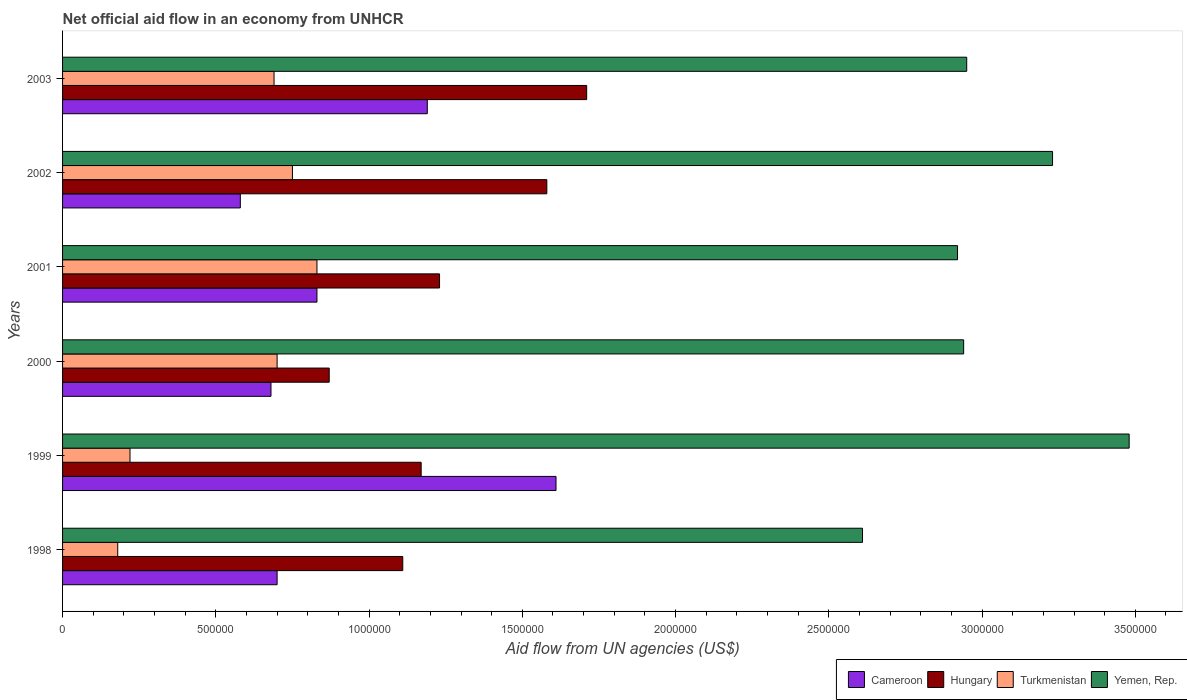How many different coloured bars are there?
Ensure brevity in your answer.  4. How many groups of bars are there?
Offer a very short reply. 6. Are the number of bars per tick equal to the number of legend labels?
Your response must be concise. Yes. Are the number of bars on each tick of the Y-axis equal?
Offer a terse response. Yes. How many bars are there on the 3rd tick from the bottom?
Provide a succinct answer. 4. What is the net official aid flow in Cameroon in 1998?
Your answer should be very brief. 7.00e+05. Across all years, what is the maximum net official aid flow in Cameroon?
Make the answer very short. 1.61e+06. Across all years, what is the minimum net official aid flow in Yemen, Rep.?
Provide a short and direct response. 2.61e+06. In which year was the net official aid flow in Hungary maximum?
Your answer should be compact. 2003. In which year was the net official aid flow in Yemen, Rep. minimum?
Make the answer very short. 1998. What is the total net official aid flow in Cameroon in the graph?
Ensure brevity in your answer.  5.59e+06. What is the difference between the net official aid flow in Yemen, Rep. in 1998 and that in 2000?
Your answer should be compact. -3.30e+05. What is the average net official aid flow in Turkmenistan per year?
Provide a succinct answer. 5.62e+05. In the year 1999, what is the difference between the net official aid flow in Turkmenistan and net official aid flow in Yemen, Rep.?
Your response must be concise. -3.26e+06. What is the ratio of the net official aid flow in Turkmenistan in 1999 to that in 2001?
Give a very brief answer. 0.27. What is the difference between the highest and the second highest net official aid flow in Hungary?
Give a very brief answer. 1.30e+05. What is the difference between the highest and the lowest net official aid flow in Yemen, Rep.?
Ensure brevity in your answer.  8.70e+05. What does the 1st bar from the top in 1999 represents?
Your answer should be very brief. Yemen, Rep. What does the 4th bar from the bottom in 2002 represents?
Ensure brevity in your answer.  Yemen, Rep. How many bars are there?
Provide a short and direct response. 24. Are all the bars in the graph horizontal?
Ensure brevity in your answer.  Yes. How many years are there in the graph?
Ensure brevity in your answer.  6. Are the values on the major ticks of X-axis written in scientific E-notation?
Your answer should be compact. No. Does the graph contain any zero values?
Keep it short and to the point. No. How many legend labels are there?
Give a very brief answer. 4. How are the legend labels stacked?
Keep it short and to the point. Horizontal. What is the title of the graph?
Keep it short and to the point. Net official aid flow in an economy from UNHCR. Does "Lesotho" appear as one of the legend labels in the graph?
Your answer should be very brief. No. What is the label or title of the X-axis?
Provide a short and direct response. Aid flow from UN agencies (US$). What is the Aid flow from UN agencies (US$) in Hungary in 1998?
Give a very brief answer. 1.11e+06. What is the Aid flow from UN agencies (US$) in Yemen, Rep. in 1998?
Keep it short and to the point. 2.61e+06. What is the Aid flow from UN agencies (US$) of Cameroon in 1999?
Ensure brevity in your answer.  1.61e+06. What is the Aid flow from UN agencies (US$) in Hungary in 1999?
Provide a short and direct response. 1.17e+06. What is the Aid flow from UN agencies (US$) of Turkmenistan in 1999?
Your answer should be very brief. 2.20e+05. What is the Aid flow from UN agencies (US$) in Yemen, Rep. in 1999?
Provide a short and direct response. 3.48e+06. What is the Aid flow from UN agencies (US$) in Cameroon in 2000?
Give a very brief answer. 6.80e+05. What is the Aid flow from UN agencies (US$) in Hungary in 2000?
Give a very brief answer. 8.70e+05. What is the Aid flow from UN agencies (US$) of Turkmenistan in 2000?
Ensure brevity in your answer.  7.00e+05. What is the Aid flow from UN agencies (US$) of Yemen, Rep. in 2000?
Your answer should be compact. 2.94e+06. What is the Aid flow from UN agencies (US$) of Cameroon in 2001?
Give a very brief answer. 8.30e+05. What is the Aid flow from UN agencies (US$) of Hungary in 2001?
Your answer should be very brief. 1.23e+06. What is the Aid flow from UN agencies (US$) of Turkmenistan in 2001?
Your response must be concise. 8.30e+05. What is the Aid flow from UN agencies (US$) in Yemen, Rep. in 2001?
Your answer should be compact. 2.92e+06. What is the Aid flow from UN agencies (US$) in Cameroon in 2002?
Keep it short and to the point. 5.80e+05. What is the Aid flow from UN agencies (US$) in Hungary in 2002?
Provide a short and direct response. 1.58e+06. What is the Aid flow from UN agencies (US$) of Turkmenistan in 2002?
Ensure brevity in your answer.  7.50e+05. What is the Aid flow from UN agencies (US$) of Yemen, Rep. in 2002?
Keep it short and to the point. 3.23e+06. What is the Aid flow from UN agencies (US$) of Cameroon in 2003?
Your answer should be very brief. 1.19e+06. What is the Aid flow from UN agencies (US$) in Hungary in 2003?
Ensure brevity in your answer.  1.71e+06. What is the Aid flow from UN agencies (US$) in Turkmenistan in 2003?
Offer a terse response. 6.90e+05. What is the Aid flow from UN agencies (US$) of Yemen, Rep. in 2003?
Keep it short and to the point. 2.95e+06. Across all years, what is the maximum Aid flow from UN agencies (US$) in Cameroon?
Your answer should be compact. 1.61e+06. Across all years, what is the maximum Aid flow from UN agencies (US$) of Hungary?
Ensure brevity in your answer.  1.71e+06. Across all years, what is the maximum Aid flow from UN agencies (US$) in Turkmenistan?
Provide a succinct answer. 8.30e+05. Across all years, what is the maximum Aid flow from UN agencies (US$) of Yemen, Rep.?
Keep it short and to the point. 3.48e+06. Across all years, what is the minimum Aid flow from UN agencies (US$) of Cameroon?
Ensure brevity in your answer.  5.80e+05. Across all years, what is the minimum Aid flow from UN agencies (US$) in Hungary?
Provide a succinct answer. 8.70e+05. Across all years, what is the minimum Aid flow from UN agencies (US$) of Turkmenistan?
Your answer should be very brief. 1.80e+05. Across all years, what is the minimum Aid flow from UN agencies (US$) of Yemen, Rep.?
Provide a short and direct response. 2.61e+06. What is the total Aid flow from UN agencies (US$) of Cameroon in the graph?
Provide a short and direct response. 5.59e+06. What is the total Aid flow from UN agencies (US$) of Hungary in the graph?
Ensure brevity in your answer.  7.67e+06. What is the total Aid flow from UN agencies (US$) of Turkmenistan in the graph?
Offer a very short reply. 3.37e+06. What is the total Aid flow from UN agencies (US$) in Yemen, Rep. in the graph?
Offer a very short reply. 1.81e+07. What is the difference between the Aid flow from UN agencies (US$) of Cameroon in 1998 and that in 1999?
Offer a very short reply. -9.10e+05. What is the difference between the Aid flow from UN agencies (US$) of Yemen, Rep. in 1998 and that in 1999?
Your response must be concise. -8.70e+05. What is the difference between the Aid flow from UN agencies (US$) of Cameroon in 1998 and that in 2000?
Make the answer very short. 2.00e+04. What is the difference between the Aid flow from UN agencies (US$) of Hungary in 1998 and that in 2000?
Offer a very short reply. 2.40e+05. What is the difference between the Aid flow from UN agencies (US$) in Turkmenistan in 1998 and that in 2000?
Your response must be concise. -5.20e+05. What is the difference between the Aid flow from UN agencies (US$) of Yemen, Rep. in 1998 and that in 2000?
Your answer should be very brief. -3.30e+05. What is the difference between the Aid flow from UN agencies (US$) in Cameroon in 1998 and that in 2001?
Offer a terse response. -1.30e+05. What is the difference between the Aid flow from UN agencies (US$) in Turkmenistan in 1998 and that in 2001?
Provide a succinct answer. -6.50e+05. What is the difference between the Aid flow from UN agencies (US$) of Yemen, Rep. in 1998 and that in 2001?
Make the answer very short. -3.10e+05. What is the difference between the Aid flow from UN agencies (US$) of Cameroon in 1998 and that in 2002?
Make the answer very short. 1.20e+05. What is the difference between the Aid flow from UN agencies (US$) in Hungary in 1998 and that in 2002?
Make the answer very short. -4.70e+05. What is the difference between the Aid flow from UN agencies (US$) in Turkmenistan in 1998 and that in 2002?
Ensure brevity in your answer.  -5.70e+05. What is the difference between the Aid flow from UN agencies (US$) of Yemen, Rep. in 1998 and that in 2002?
Keep it short and to the point. -6.20e+05. What is the difference between the Aid flow from UN agencies (US$) of Cameroon in 1998 and that in 2003?
Give a very brief answer. -4.90e+05. What is the difference between the Aid flow from UN agencies (US$) in Hungary in 1998 and that in 2003?
Offer a terse response. -6.00e+05. What is the difference between the Aid flow from UN agencies (US$) of Turkmenistan in 1998 and that in 2003?
Give a very brief answer. -5.10e+05. What is the difference between the Aid flow from UN agencies (US$) of Yemen, Rep. in 1998 and that in 2003?
Make the answer very short. -3.40e+05. What is the difference between the Aid flow from UN agencies (US$) in Cameroon in 1999 and that in 2000?
Offer a terse response. 9.30e+05. What is the difference between the Aid flow from UN agencies (US$) in Turkmenistan in 1999 and that in 2000?
Your answer should be very brief. -4.80e+05. What is the difference between the Aid flow from UN agencies (US$) of Yemen, Rep. in 1999 and that in 2000?
Keep it short and to the point. 5.40e+05. What is the difference between the Aid flow from UN agencies (US$) in Cameroon in 1999 and that in 2001?
Provide a succinct answer. 7.80e+05. What is the difference between the Aid flow from UN agencies (US$) in Turkmenistan in 1999 and that in 2001?
Your answer should be compact. -6.10e+05. What is the difference between the Aid flow from UN agencies (US$) in Yemen, Rep. in 1999 and that in 2001?
Your response must be concise. 5.60e+05. What is the difference between the Aid flow from UN agencies (US$) of Cameroon in 1999 and that in 2002?
Your response must be concise. 1.03e+06. What is the difference between the Aid flow from UN agencies (US$) in Hungary in 1999 and that in 2002?
Offer a very short reply. -4.10e+05. What is the difference between the Aid flow from UN agencies (US$) in Turkmenistan in 1999 and that in 2002?
Give a very brief answer. -5.30e+05. What is the difference between the Aid flow from UN agencies (US$) of Yemen, Rep. in 1999 and that in 2002?
Your answer should be compact. 2.50e+05. What is the difference between the Aid flow from UN agencies (US$) in Cameroon in 1999 and that in 2003?
Your answer should be very brief. 4.20e+05. What is the difference between the Aid flow from UN agencies (US$) in Hungary in 1999 and that in 2003?
Keep it short and to the point. -5.40e+05. What is the difference between the Aid flow from UN agencies (US$) of Turkmenistan in 1999 and that in 2003?
Give a very brief answer. -4.70e+05. What is the difference between the Aid flow from UN agencies (US$) of Yemen, Rep. in 1999 and that in 2003?
Give a very brief answer. 5.30e+05. What is the difference between the Aid flow from UN agencies (US$) in Cameroon in 2000 and that in 2001?
Make the answer very short. -1.50e+05. What is the difference between the Aid flow from UN agencies (US$) of Hungary in 2000 and that in 2001?
Your answer should be compact. -3.60e+05. What is the difference between the Aid flow from UN agencies (US$) of Turkmenistan in 2000 and that in 2001?
Your answer should be compact. -1.30e+05. What is the difference between the Aid flow from UN agencies (US$) of Yemen, Rep. in 2000 and that in 2001?
Make the answer very short. 2.00e+04. What is the difference between the Aid flow from UN agencies (US$) in Cameroon in 2000 and that in 2002?
Give a very brief answer. 1.00e+05. What is the difference between the Aid flow from UN agencies (US$) of Hungary in 2000 and that in 2002?
Give a very brief answer. -7.10e+05. What is the difference between the Aid flow from UN agencies (US$) in Yemen, Rep. in 2000 and that in 2002?
Offer a very short reply. -2.90e+05. What is the difference between the Aid flow from UN agencies (US$) in Cameroon in 2000 and that in 2003?
Your answer should be compact. -5.10e+05. What is the difference between the Aid flow from UN agencies (US$) of Hungary in 2000 and that in 2003?
Ensure brevity in your answer.  -8.40e+05. What is the difference between the Aid flow from UN agencies (US$) in Turkmenistan in 2000 and that in 2003?
Provide a short and direct response. 10000. What is the difference between the Aid flow from UN agencies (US$) of Cameroon in 2001 and that in 2002?
Your answer should be very brief. 2.50e+05. What is the difference between the Aid flow from UN agencies (US$) in Hungary in 2001 and that in 2002?
Offer a very short reply. -3.50e+05. What is the difference between the Aid flow from UN agencies (US$) in Yemen, Rep. in 2001 and that in 2002?
Offer a terse response. -3.10e+05. What is the difference between the Aid flow from UN agencies (US$) of Cameroon in 2001 and that in 2003?
Make the answer very short. -3.60e+05. What is the difference between the Aid flow from UN agencies (US$) in Hungary in 2001 and that in 2003?
Make the answer very short. -4.80e+05. What is the difference between the Aid flow from UN agencies (US$) in Yemen, Rep. in 2001 and that in 2003?
Ensure brevity in your answer.  -3.00e+04. What is the difference between the Aid flow from UN agencies (US$) in Cameroon in 2002 and that in 2003?
Provide a succinct answer. -6.10e+05. What is the difference between the Aid flow from UN agencies (US$) of Hungary in 2002 and that in 2003?
Make the answer very short. -1.30e+05. What is the difference between the Aid flow from UN agencies (US$) in Turkmenistan in 2002 and that in 2003?
Keep it short and to the point. 6.00e+04. What is the difference between the Aid flow from UN agencies (US$) of Yemen, Rep. in 2002 and that in 2003?
Your answer should be very brief. 2.80e+05. What is the difference between the Aid flow from UN agencies (US$) of Cameroon in 1998 and the Aid flow from UN agencies (US$) of Hungary in 1999?
Provide a succinct answer. -4.70e+05. What is the difference between the Aid flow from UN agencies (US$) of Cameroon in 1998 and the Aid flow from UN agencies (US$) of Yemen, Rep. in 1999?
Your answer should be very brief. -2.78e+06. What is the difference between the Aid flow from UN agencies (US$) of Hungary in 1998 and the Aid flow from UN agencies (US$) of Turkmenistan in 1999?
Your response must be concise. 8.90e+05. What is the difference between the Aid flow from UN agencies (US$) of Hungary in 1998 and the Aid flow from UN agencies (US$) of Yemen, Rep. in 1999?
Your response must be concise. -2.37e+06. What is the difference between the Aid flow from UN agencies (US$) in Turkmenistan in 1998 and the Aid flow from UN agencies (US$) in Yemen, Rep. in 1999?
Your response must be concise. -3.30e+06. What is the difference between the Aid flow from UN agencies (US$) in Cameroon in 1998 and the Aid flow from UN agencies (US$) in Hungary in 2000?
Your answer should be compact. -1.70e+05. What is the difference between the Aid flow from UN agencies (US$) of Cameroon in 1998 and the Aid flow from UN agencies (US$) of Turkmenistan in 2000?
Give a very brief answer. 0. What is the difference between the Aid flow from UN agencies (US$) in Cameroon in 1998 and the Aid flow from UN agencies (US$) in Yemen, Rep. in 2000?
Offer a very short reply. -2.24e+06. What is the difference between the Aid flow from UN agencies (US$) in Hungary in 1998 and the Aid flow from UN agencies (US$) in Turkmenistan in 2000?
Your answer should be compact. 4.10e+05. What is the difference between the Aid flow from UN agencies (US$) of Hungary in 1998 and the Aid flow from UN agencies (US$) of Yemen, Rep. in 2000?
Your answer should be very brief. -1.83e+06. What is the difference between the Aid flow from UN agencies (US$) in Turkmenistan in 1998 and the Aid flow from UN agencies (US$) in Yemen, Rep. in 2000?
Provide a succinct answer. -2.76e+06. What is the difference between the Aid flow from UN agencies (US$) in Cameroon in 1998 and the Aid flow from UN agencies (US$) in Hungary in 2001?
Offer a very short reply. -5.30e+05. What is the difference between the Aid flow from UN agencies (US$) of Cameroon in 1998 and the Aid flow from UN agencies (US$) of Yemen, Rep. in 2001?
Offer a very short reply. -2.22e+06. What is the difference between the Aid flow from UN agencies (US$) in Hungary in 1998 and the Aid flow from UN agencies (US$) in Yemen, Rep. in 2001?
Provide a succinct answer. -1.81e+06. What is the difference between the Aid flow from UN agencies (US$) in Turkmenistan in 1998 and the Aid flow from UN agencies (US$) in Yemen, Rep. in 2001?
Your response must be concise. -2.74e+06. What is the difference between the Aid flow from UN agencies (US$) of Cameroon in 1998 and the Aid flow from UN agencies (US$) of Hungary in 2002?
Your response must be concise. -8.80e+05. What is the difference between the Aid flow from UN agencies (US$) of Cameroon in 1998 and the Aid flow from UN agencies (US$) of Turkmenistan in 2002?
Your answer should be compact. -5.00e+04. What is the difference between the Aid flow from UN agencies (US$) in Cameroon in 1998 and the Aid flow from UN agencies (US$) in Yemen, Rep. in 2002?
Offer a very short reply. -2.53e+06. What is the difference between the Aid flow from UN agencies (US$) of Hungary in 1998 and the Aid flow from UN agencies (US$) of Turkmenistan in 2002?
Offer a terse response. 3.60e+05. What is the difference between the Aid flow from UN agencies (US$) in Hungary in 1998 and the Aid flow from UN agencies (US$) in Yemen, Rep. in 2002?
Offer a terse response. -2.12e+06. What is the difference between the Aid flow from UN agencies (US$) in Turkmenistan in 1998 and the Aid flow from UN agencies (US$) in Yemen, Rep. in 2002?
Ensure brevity in your answer.  -3.05e+06. What is the difference between the Aid flow from UN agencies (US$) of Cameroon in 1998 and the Aid flow from UN agencies (US$) of Hungary in 2003?
Make the answer very short. -1.01e+06. What is the difference between the Aid flow from UN agencies (US$) of Cameroon in 1998 and the Aid flow from UN agencies (US$) of Turkmenistan in 2003?
Offer a very short reply. 10000. What is the difference between the Aid flow from UN agencies (US$) in Cameroon in 1998 and the Aid flow from UN agencies (US$) in Yemen, Rep. in 2003?
Offer a terse response. -2.25e+06. What is the difference between the Aid flow from UN agencies (US$) in Hungary in 1998 and the Aid flow from UN agencies (US$) in Turkmenistan in 2003?
Provide a short and direct response. 4.20e+05. What is the difference between the Aid flow from UN agencies (US$) in Hungary in 1998 and the Aid flow from UN agencies (US$) in Yemen, Rep. in 2003?
Your answer should be very brief. -1.84e+06. What is the difference between the Aid flow from UN agencies (US$) of Turkmenistan in 1998 and the Aid flow from UN agencies (US$) of Yemen, Rep. in 2003?
Provide a succinct answer. -2.77e+06. What is the difference between the Aid flow from UN agencies (US$) of Cameroon in 1999 and the Aid flow from UN agencies (US$) of Hungary in 2000?
Ensure brevity in your answer.  7.40e+05. What is the difference between the Aid flow from UN agencies (US$) of Cameroon in 1999 and the Aid flow from UN agencies (US$) of Turkmenistan in 2000?
Offer a terse response. 9.10e+05. What is the difference between the Aid flow from UN agencies (US$) of Cameroon in 1999 and the Aid flow from UN agencies (US$) of Yemen, Rep. in 2000?
Provide a succinct answer. -1.33e+06. What is the difference between the Aid flow from UN agencies (US$) of Hungary in 1999 and the Aid flow from UN agencies (US$) of Yemen, Rep. in 2000?
Give a very brief answer. -1.77e+06. What is the difference between the Aid flow from UN agencies (US$) in Turkmenistan in 1999 and the Aid flow from UN agencies (US$) in Yemen, Rep. in 2000?
Provide a succinct answer. -2.72e+06. What is the difference between the Aid flow from UN agencies (US$) of Cameroon in 1999 and the Aid flow from UN agencies (US$) of Hungary in 2001?
Offer a terse response. 3.80e+05. What is the difference between the Aid flow from UN agencies (US$) of Cameroon in 1999 and the Aid flow from UN agencies (US$) of Turkmenistan in 2001?
Your answer should be very brief. 7.80e+05. What is the difference between the Aid flow from UN agencies (US$) in Cameroon in 1999 and the Aid flow from UN agencies (US$) in Yemen, Rep. in 2001?
Your answer should be compact. -1.31e+06. What is the difference between the Aid flow from UN agencies (US$) in Hungary in 1999 and the Aid flow from UN agencies (US$) in Turkmenistan in 2001?
Ensure brevity in your answer.  3.40e+05. What is the difference between the Aid flow from UN agencies (US$) in Hungary in 1999 and the Aid flow from UN agencies (US$) in Yemen, Rep. in 2001?
Offer a terse response. -1.75e+06. What is the difference between the Aid flow from UN agencies (US$) of Turkmenistan in 1999 and the Aid flow from UN agencies (US$) of Yemen, Rep. in 2001?
Keep it short and to the point. -2.70e+06. What is the difference between the Aid flow from UN agencies (US$) of Cameroon in 1999 and the Aid flow from UN agencies (US$) of Hungary in 2002?
Your response must be concise. 3.00e+04. What is the difference between the Aid flow from UN agencies (US$) in Cameroon in 1999 and the Aid flow from UN agencies (US$) in Turkmenistan in 2002?
Ensure brevity in your answer.  8.60e+05. What is the difference between the Aid flow from UN agencies (US$) of Cameroon in 1999 and the Aid flow from UN agencies (US$) of Yemen, Rep. in 2002?
Provide a succinct answer. -1.62e+06. What is the difference between the Aid flow from UN agencies (US$) of Hungary in 1999 and the Aid flow from UN agencies (US$) of Yemen, Rep. in 2002?
Give a very brief answer. -2.06e+06. What is the difference between the Aid flow from UN agencies (US$) in Turkmenistan in 1999 and the Aid flow from UN agencies (US$) in Yemen, Rep. in 2002?
Provide a short and direct response. -3.01e+06. What is the difference between the Aid flow from UN agencies (US$) in Cameroon in 1999 and the Aid flow from UN agencies (US$) in Turkmenistan in 2003?
Your answer should be very brief. 9.20e+05. What is the difference between the Aid flow from UN agencies (US$) of Cameroon in 1999 and the Aid flow from UN agencies (US$) of Yemen, Rep. in 2003?
Provide a short and direct response. -1.34e+06. What is the difference between the Aid flow from UN agencies (US$) in Hungary in 1999 and the Aid flow from UN agencies (US$) in Yemen, Rep. in 2003?
Your answer should be compact. -1.78e+06. What is the difference between the Aid flow from UN agencies (US$) of Turkmenistan in 1999 and the Aid flow from UN agencies (US$) of Yemen, Rep. in 2003?
Provide a succinct answer. -2.73e+06. What is the difference between the Aid flow from UN agencies (US$) in Cameroon in 2000 and the Aid flow from UN agencies (US$) in Hungary in 2001?
Make the answer very short. -5.50e+05. What is the difference between the Aid flow from UN agencies (US$) of Cameroon in 2000 and the Aid flow from UN agencies (US$) of Yemen, Rep. in 2001?
Ensure brevity in your answer.  -2.24e+06. What is the difference between the Aid flow from UN agencies (US$) of Hungary in 2000 and the Aid flow from UN agencies (US$) of Turkmenistan in 2001?
Provide a short and direct response. 4.00e+04. What is the difference between the Aid flow from UN agencies (US$) of Hungary in 2000 and the Aid flow from UN agencies (US$) of Yemen, Rep. in 2001?
Make the answer very short. -2.05e+06. What is the difference between the Aid flow from UN agencies (US$) of Turkmenistan in 2000 and the Aid flow from UN agencies (US$) of Yemen, Rep. in 2001?
Provide a short and direct response. -2.22e+06. What is the difference between the Aid flow from UN agencies (US$) in Cameroon in 2000 and the Aid flow from UN agencies (US$) in Hungary in 2002?
Your answer should be very brief. -9.00e+05. What is the difference between the Aid flow from UN agencies (US$) in Cameroon in 2000 and the Aid flow from UN agencies (US$) in Yemen, Rep. in 2002?
Ensure brevity in your answer.  -2.55e+06. What is the difference between the Aid flow from UN agencies (US$) of Hungary in 2000 and the Aid flow from UN agencies (US$) of Yemen, Rep. in 2002?
Your answer should be very brief. -2.36e+06. What is the difference between the Aid flow from UN agencies (US$) of Turkmenistan in 2000 and the Aid flow from UN agencies (US$) of Yemen, Rep. in 2002?
Provide a succinct answer. -2.53e+06. What is the difference between the Aid flow from UN agencies (US$) in Cameroon in 2000 and the Aid flow from UN agencies (US$) in Hungary in 2003?
Offer a terse response. -1.03e+06. What is the difference between the Aid flow from UN agencies (US$) of Cameroon in 2000 and the Aid flow from UN agencies (US$) of Turkmenistan in 2003?
Your response must be concise. -10000. What is the difference between the Aid flow from UN agencies (US$) of Cameroon in 2000 and the Aid flow from UN agencies (US$) of Yemen, Rep. in 2003?
Your response must be concise. -2.27e+06. What is the difference between the Aid flow from UN agencies (US$) in Hungary in 2000 and the Aid flow from UN agencies (US$) in Turkmenistan in 2003?
Offer a very short reply. 1.80e+05. What is the difference between the Aid flow from UN agencies (US$) in Hungary in 2000 and the Aid flow from UN agencies (US$) in Yemen, Rep. in 2003?
Provide a succinct answer. -2.08e+06. What is the difference between the Aid flow from UN agencies (US$) in Turkmenistan in 2000 and the Aid flow from UN agencies (US$) in Yemen, Rep. in 2003?
Offer a very short reply. -2.25e+06. What is the difference between the Aid flow from UN agencies (US$) of Cameroon in 2001 and the Aid flow from UN agencies (US$) of Hungary in 2002?
Offer a very short reply. -7.50e+05. What is the difference between the Aid flow from UN agencies (US$) in Cameroon in 2001 and the Aid flow from UN agencies (US$) in Turkmenistan in 2002?
Offer a very short reply. 8.00e+04. What is the difference between the Aid flow from UN agencies (US$) in Cameroon in 2001 and the Aid flow from UN agencies (US$) in Yemen, Rep. in 2002?
Ensure brevity in your answer.  -2.40e+06. What is the difference between the Aid flow from UN agencies (US$) in Hungary in 2001 and the Aid flow from UN agencies (US$) in Yemen, Rep. in 2002?
Keep it short and to the point. -2.00e+06. What is the difference between the Aid flow from UN agencies (US$) in Turkmenistan in 2001 and the Aid flow from UN agencies (US$) in Yemen, Rep. in 2002?
Make the answer very short. -2.40e+06. What is the difference between the Aid flow from UN agencies (US$) of Cameroon in 2001 and the Aid flow from UN agencies (US$) of Hungary in 2003?
Make the answer very short. -8.80e+05. What is the difference between the Aid flow from UN agencies (US$) of Cameroon in 2001 and the Aid flow from UN agencies (US$) of Turkmenistan in 2003?
Make the answer very short. 1.40e+05. What is the difference between the Aid flow from UN agencies (US$) in Cameroon in 2001 and the Aid flow from UN agencies (US$) in Yemen, Rep. in 2003?
Your answer should be compact. -2.12e+06. What is the difference between the Aid flow from UN agencies (US$) of Hungary in 2001 and the Aid flow from UN agencies (US$) of Turkmenistan in 2003?
Your answer should be compact. 5.40e+05. What is the difference between the Aid flow from UN agencies (US$) in Hungary in 2001 and the Aid flow from UN agencies (US$) in Yemen, Rep. in 2003?
Offer a very short reply. -1.72e+06. What is the difference between the Aid flow from UN agencies (US$) in Turkmenistan in 2001 and the Aid flow from UN agencies (US$) in Yemen, Rep. in 2003?
Provide a succinct answer. -2.12e+06. What is the difference between the Aid flow from UN agencies (US$) in Cameroon in 2002 and the Aid flow from UN agencies (US$) in Hungary in 2003?
Provide a short and direct response. -1.13e+06. What is the difference between the Aid flow from UN agencies (US$) in Cameroon in 2002 and the Aid flow from UN agencies (US$) in Yemen, Rep. in 2003?
Your answer should be compact. -2.37e+06. What is the difference between the Aid flow from UN agencies (US$) in Hungary in 2002 and the Aid flow from UN agencies (US$) in Turkmenistan in 2003?
Give a very brief answer. 8.90e+05. What is the difference between the Aid flow from UN agencies (US$) of Hungary in 2002 and the Aid flow from UN agencies (US$) of Yemen, Rep. in 2003?
Keep it short and to the point. -1.37e+06. What is the difference between the Aid flow from UN agencies (US$) of Turkmenistan in 2002 and the Aid flow from UN agencies (US$) of Yemen, Rep. in 2003?
Offer a terse response. -2.20e+06. What is the average Aid flow from UN agencies (US$) in Cameroon per year?
Your response must be concise. 9.32e+05. What is the average Aid flow from UN agencies (US$) in Hungary per year?
Give a very brief answer. 1.28e+06. What is the average Aid flow from UN agencies (US$) in Turkmenistan per year?
Your response must be concise. 5.62e+05. What is the average Aid flow from UN agencies (US$) of Yemen, Rep. per year?
Keep it short and to the point. 3.02e+06. In the year 1998, what is the difference between the Aid flow from UN agencies (US$) in Cameroon and Aid flow from UN agencies (US$) in Hungary?
Provide a succinct answer. -4.10e+05. In the year 1998, what is the difference between the Aid flow from UN agencies (US$) of Cameroon and Aid flow from UN agencies (US$) of Turkmenistan?
Offer a very short reply. 5.20e+05. In the year 1998, what is the difference between the Aid flow from UN agencies (US$) in Cameroon and Aid flow from UN agencies (US$) in Yemen, Rep.?
Keep it short and to the point. -1.91e+06. In the year 1998, what is the difference between the Aid flow from UN agencies (US$) of Hungary and Aid flow from UN agencies (US$) of Turkmenistan?
Make the answer very short. 9.30e+05. In the year 1998, what is the difference between the Aid flow from UN agencies (US$) of Hungary and Aid flow from UN agencies (US$) of Yemen, Rep.?
Offer a terse response. -1.50e+06. In the year 1998, what is the difference between the Aid flow from UN agencies (US$) of Turkmenistan and Aid flow from UN agencies (US$) of Yemen, Rep.?
Your answer should be very brief. -2.43e+06. In the year 1999, what is the difference between the Aid flow from UN agencies (US$) of Cameroon and Aid flow from UN agencies (US$) of Turkmenistan?
Your answer should be compact. 1.39e+06. In the year 1999, what is the difference between the Aid flow from UN agencies (US$) of Cameroon and Aid flow from UN agencies (US$) of Yemen, Rep.?
Your answer should be compact. -1.87e+06. In the year 1999, what is the difference between the Aid flow from UN agencies (US$) of Hungary and Aid flow from UN agencies (US$) of Turkmenistan?
Keep it short and to the point. 9.50e+05. In the year 1999, what is the difference between the Aid flow from UN agencies (US$) in Hungary and Aid flow from UN agencies (US$) in Yemen, Rep.?
Offer a terse response. -2.31e+06. In the year 1999, what is the difference between the Aid flow from UN agencies (US$) of Turkmenistan and Aid flow from UN agencies (US$) of Yemen, Rep.?
Make the answer very short. -3.26e+06. In the year 2000, what is the difference between the Aid flow from UN agencies (US$) in Cameroon and Aid flow from UN agencies (US$) in Hungary?
Keep it short and to the point. -1.90e+05. In the year 2000, what is the difference between the Aid flow from UN agencies (US$) in Cameroon and Aid flow from UN agencies (US$) in Yemen, Rep.?
Provide a succinct answer. -2.26e+06. In the year 2000, what is the difference between the Aid flow from UN agencies (US$) of Hungary and Aid flow from UN agencies (US$) of Yemen, Rep.?
Your response must be concise. -2.07e+06. In the year 2000, what is the difference between the Aid flow from UN agencies (US$) in Turkmenistan and Aid flow from UN agencies (US$) in Yemen, Rep.?
Offer a very short reply. -2.24e+06. In the year 2001, what is the difference between the Aid flow from UN agencies (US$) in Cameroon and Aid flow from UN agencies (US$) in Hungary?
Keep it short and to the point. -4.00e+05. In the year 2001, what is the difference between the Aid flow from UN agencies (US$) of Cameroon and Aid flow from UN agencies (US$) of Turkmenistan?
Offer a very short reply. 0. In the year 2001, what is the difference between the Aid flow from UN agencies (US$) of Cameroon and Aid flow from UN agencies (US$) of Yemen, Rep.?
Give a very brief answer. -2.09e+06. In the year 2001, what is the difference between the Aid flow from UN agencies (US$) of Hungary and Aid flow from UN agencies (US$) of Turkmenistan?
Your response must be concise. 4.00e+05. In the year 2001, what is the difference between the Aid flow from UN agencies (US$) of Hungary and Aid flow from UN agencies (US$) of Yemen, Rep.?
Make the answer very short. -1.69e+06. In the year 2001, what is the difference between the Aid flow from UN agencies (US$) in Turkmenistan and Aid flow from UN agencies (US$) in Yemen, Rep.?
Give a very brief answer. -2.09e+06. In the year 2002, what is the difference between the Aid flow from UN agencies (US$) of Cameroon and Aid flow from UN agencies (US$) of Yemen, Rep.?
Offer a terse response. -2.65e+06. In the year 2002, what is the difference between the Aid flow from UN agencies (US$) in Hungary and Aid flow from UN agencies (US$) in Turkmenistan?
Offer a terse response. 8.30e+05. In the year 2002, what is the difference between the Aid flow from UN agencies (US$) of Hungary and Aid flow from UN agencies (US$) of Yemen, Rep.?
Your answer should be compact. -1.65e+06. In the year 2002, what is the difference between the Aid flow from UN agencies (US$) of Turkmenistan and Aid flow from UN agencies (US$) of Yemen, Rep.?
Your response must be concise. -2.48e+06. In the year 2003, what is the difference between the Aid flow from UN agencies (US$) of Cameroon and Aid flow from UN agencies (US$) of Hungary?
Keep it short and to the point. -5.20e+05. In the year 2003, what is the difference between the Aid flow from UN agencies (US$) in Cameroon and Aid flow from UN agencies (US$) in Yemen, Rep.?
Provide a succinct answer. -1.76e+06. In the year 2003, what is the difference between the Aid flow from UN agencies (US$) in Hungary and Aid flow from UN agencies (US$) in Turkmenistan?
Offer a very short reply. 1.02e+06. In the year 2003, what is the difference between the Aid flow from UN agencies (US$) in Hungary and Aid flow from UN agencies (US$) in Yemen, Rep.?
Make the answer very short. -1.24e+06. In the year 2003, what is the difference between the Aid flow from UN agencies (US$) in Turkmenistan and Aid flow from UN agencies (US$) in Yemen, Rep.?
Make the answer very short. -2.26e+06. What is the ratio of the Aid flow from UN agencies (US$) of Cameroon in 1998 to that in 1999?
Give a very brief answer. 0.43. What is the ratio of the Aid flow from UN agencies (US$) in Hungary in 1998 to that in 1999?
Ensure brevity in your answer.  0.95. What is the ratio of the Aid flow from UN agencies (US$) in Turkmenistan in 1998 to that in 1999?
Give a very brief answer. 0.82. What is the ratio of the Aid flow from UN agencies (US$) of Yemen, Rep. in 1998 to that in 1999?
Offer a very short reply. 0.75. What is the ratio of the Aid flow from UN agencies (US$) of Cameroon in 1998 to that in 2000?
Your response must be concise. 1.03. What is the ratio of the Aid flow from UN agencies (US$) in Hungary in 1998 to that in 2000?
Your answer should be very brief. 1.28. What is the ratio of the Aid flow from UN agencies (US$) in Turkmenistan in 1998 to that in 2000?
Your response must be concise. 0.26. What is the ratio of the Aid flow from UN agencies (US$) of Yemen, Rep. in 1998 to that in 2000?
Provide a short and direct response. 0.89. What is the ratio of the Aid flow from UN agencies (US$) in Cameroon in 1998 to that in 2001?
Provide a short and direct response. 0.84. What is the ratio of the Aid flow from UN agencies (US$) in Hungary in 1998 to that in 2001?
Give a very brief answer. 0.9. What is the ratio of the Aid flow from UN agencies (US$) of Turkmenistan in 1998 to that in 2001?
Offer a very short reply. 0.22. What is the ratio of the Aid flow from UN agencies (US$) of Yemen, Rep. in 1998 to that in 2001?
Offer a very short reply. 0.89. What is the ratio of the Aid flow from UN agencies (US$) in Cameroon in 1998 to that in 2002?
Offer a very short reply. 1.21. What is the ratio of the Aid flow from UN agencies (US$) in Hungary in 1998 to that in 2002?
Offer a terse response. 0.7. What is the ratio of the Aid flow from UN agencies (US$) of Turkmenistan in 1998 to that in 2002?
Keep it short and to the point. 0.24. What is the ratio of the Aid flow from UN agencies (US$) of Yemen, Rep. in 1998 to that in 2002?
Keep it short and to the point. 0.81. What is the ratio of the Aid flow from UN agencies (US$) in Cameroon in 1998 to that in 2003?
Your answer should be very brief. 0.59. What is the ratio of the Aid flow from UN agencies (US$) of Hungary in 1998 to that in 2003?
Offer a very short reply. 0.65. What is the ratio of the Aid flow from UN agencies (US$) of Turkmenistan in 1998 to that in 2003?
Your response must be concise. 0.26. What is the ratio of the Aid flow from UN agencies (US$) in Yemen, Rep. in 1998 to that in 2003?
Your response must be concise. 0.88. What is the ratio of the Aid flow from UN agencies (US$) in Cameroon in 1999 to that in 2000?
Your answer should be compact. 2.37. What is the ratio of the Aid flow from UN agencies (US$) in Hungary in 1999 to that in 2000?
Give a very brief answer. 1.34. What is the ratio of the Aid flow from UN agencies (US$) of Turkmenistan in 1999 to that in 2000?
Offer a very short reply. 0.31. What is the ratio of the Aid flow from UN agencies (US$) in Yemen, Rep. in 1999 to that in 2000?
Ensure brevity in your answer.  1.18. What is the ratio of the Aid flow from UN agencies (US$) in Cameroon in 1999 to that in 2001?
Give a very brief answer. 1.94. What is the ratio of the Aid flow from UN agencies (US$) of Hungary in 1999 to that in 2001?
Ensure brevity in your answer.  0.95. What is the ratio of the Aid flow from UN agencies (US$) of Turkmenistan in 1999 to that in 2001?
Keep it short and to the point. 0.27. What is the ratio of the Aid flow from UN agencies (US$) in Yemen, Rep. in 1999 to that in 2001?
Your answer should be compact. 1.19. What is the ratio of the Aid flow from UN agencies (US$) of Cameroon in 1999 to that in 2002?
Provide a short and direct response. 2.78. What is the ratio of the Aid flow from UN agencies (US$) in Hungary in 1999 to that in 2002?
Provide a short and direct response. 0.74. What is the ratio of the Aid flow from UN agencies (US$) in Turkmenistan in 1999 to that in 2002?
Give a very brief answer. 0.29. What is the ratio of the Aid flow from UN agencies (US$) of Yemen, Rep. in 1999 to that in 2002?
Your answer should be compact. 1.08. What is the ratio of the Aid flow from UN agencies (US$) of Cameroon in 1999 to that in 2003?
Your answer should be very brief. 1.35. What is the ratio of the Aid flow from UN agencies (US$) in Hungary in 1999 to that in 2003?
Offer a very short reply. 0.68. What is the ratio of the Aid flow from UN agencies (US$) in Turkmenistan in 1999 to that in 2003?
Provide a succinct answer. 0.32. What is the ratio of the Aid flow from UN agencies (US$) in Yemen, Rep. in 1999 to that in 2003?
Offer a very short reply. 1.18. What is the ratio of the Aid flow from UN agencies (US$) of Cameroon in 2000 to that in 2001?
Provide a short and direct response. 0.82. What is the ratio of the Aid flow from UN agencies (US$) in Hungary in 2000 to that in 2001?
Ensure brevity in your answer.  0.71. What is the ratio of the Aid flow from UN agencies (US$) of Turkmenistan in 2000 to that in 2001?
Offer a terse response. 0.84. What is the ratio of the Aid flow from UN agencies (US$) of Yemen, Rep. in 2000 to that in 2001?
Give a very brief answer. 1.01. What is the ratio of the Aid flow from UN agencies (US$) of Cameroon in 2000 to that in 2002?
Offer a terse response. 1.17. What is the ratio of the Aid flow from UN agencies (US$) of Hungary in 2000 to that in 2002?
Give a very brief answer. 0.55. What is the ratio of the Aid flow from UN agencies (US$) in Turkmenistan in 2000 to that in 2002?
Your response must be concise. 0.93. What is the ratio of the Aid flow from UN agencies (US$) in Yemen, Rep. in 2000 to that in 2002?
Provide a succinct answer. 0.91. What is the ratio of the Aid flow from UN agencies (US$) in Hungary in 2000 to that in 2003?
Offer a terse response. 0.51. What is the ratio of the Aid flow from UN agencies (US$) in Turkmenistan in 2000 to that in 2003?
Your response must be concise. 1.01. What is the ratio of the Aid flow from UN agencies (US$) in Cameroon in 2001 to that in 2002?
Keep it short and to the point. 1.43. What is the ratio of the Aid flow from UN agencies (US$) of Hungary in 2001 to that in 2002?
Your answer should be compact. 0.78. What is the ratio of the Aid flow from UN agencies (US$) in Turkmenistan in 2001 to that in 2002?
Provide a short and direct response. 1.11. What is the ratio of the Aid flow from UN agencies (US$) of Yemen, Rep. in 2001 to that in 2002?
Provide a short and direct response. 0.9. What is the ratio of the Aid flow from UN agencies (US$) in Cameroon in 2001 to that in 2003?
Give a very brief answer. 0.7. What is the ratio of the Aid flow from UN agencies (US$) in Hungary in 2001 to that in 2003?
Make the answer very short. 0.72. What is the ratio of the Aid flow from UN agencies (US$) in Turkmenistan in 2001 to that in 2003?
Your answer should be compact. 1.2. What is the ratio of the Aid flow from UN agencies (US$) of Cameroon in 2002 to that in 2003?
Provide a succinct answer. 0.49. What is the ratio of the Aid flow from UN agencies (US$) of Hungary in 2002 to that in 2003?
Your answer should be very brief. 0.92. What is the ratio of the Aid flow from UN agencies (US$) in Turkmenistan in 2002 to that in 2003?
Offer a terse response. 1.09. What is the ratio of the Aid flow from UN agencies (US$) in Yemen, Rep. in 2002 to that in 2003?
Keep it short and to the point. 1.09. What is the difference between the highest and the second highest Aid flow from UN agencies (US$) of Cameroon?
Offer a very short reply. 4.20e+05. What is the difference between the highest and the second highest Aid flow from UN agencies (US$) in Hungary?
Ensure brevity in your answer.  1.30e+05. What is the difference between the highest and the lowest Aid flow from UN agencies (US$) of Cameroon?
Make the answer very short. 1.03e+06. What is the difference between the highest and the lowest Aid flow from UN agencies (US$) of Hungary?
Your response must be concise. 8.40e+05. What is the difference between the highest and the lowest Aid flow from UN agencies (US$) in Turkmenistan?
Your answer should be compact. 6.50e+05. What is the difference between the highest and the lowest Aid flow from UN agencies (US$) in Yemen, Rep.?
Keep it short and to the point. 8.70e+05. 